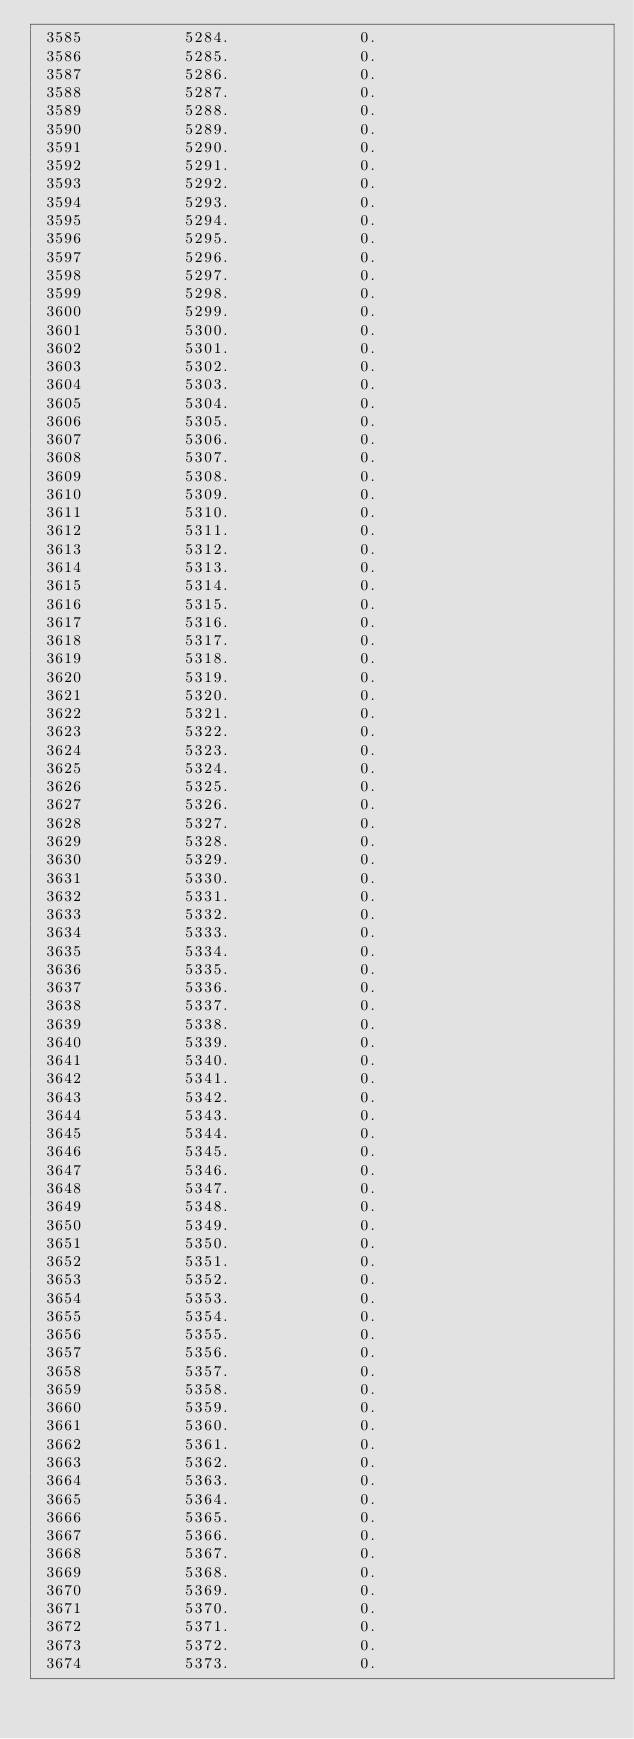Convert code to text. <code><loc_0><loc_0><loc_500><loc_500><_SQL_> 3585           5284.              0.
 3586           5285.              0.
 3587           5286.              0.
 3588           5287.              0.
 3589           5288.              0.
 3590           5289.              0.
 3591           5290.              0.
 3592           5291.              0.
 3593           5292.              0.
 3594           5293.              0.
 3595           5294.              0.
 3596           5295.              0.
 3597           5296.              0.
 3598           5297.              0.
 3599           5298.              0.
 3600           5299.              0.
 3601           5300.              0.
 3602           5301.              0.
 3603           5302.              0.
 3604           5303.              0.
 3605           5304.              0.
 3606           5305.              0.
 3607           5306.              0.
 3608           5307.              0.
 3609           5308.              0.
 3610           5309.              0.
 3611           5310.              0.
 3612           5311.              0.
 3613           5312.              0.
 3614           5313.              0.
 3615           5314.              0.
 3616           5315.              0.
 3617           5316.              0.
 3618           5317.              0.
 3619           5318.              0.
 3620           5319.              0.
 3621           5320.              0.
 3622           5321.              0.
 3623           5322.              0.
 3624           5323.              0.
 3625           5324.              0.
 3626           5325.              0.
 3627           5326.              0.
 3628           5327.              0.
 3629           5328.              0.
 3630           5329.              0.
 3631           5330.              0.
 3632           5331.              0.
 3633           5332.              0.
 3634           5333.              0.
 3635           5334.              0.
 3636           5335.              0.
 3637           5336.              0.
 3638           5337.              0.
 3639           5338.              0.
 3640           5339.              0.
 3641           5340.              0.
 3642           5341.              0.
 3643           5342.              0.
 3644           5343.              0.
 3645           5344.              0.
 3646           5345.              0.
 3647           5346.              0.
 3648           5347.              0.
 3649           5348.              0.
 3650           5349.              0.
 3651           5350.              0.
 3652           5351.              0.
 3653           5352.              0.
 3654           5353.              0.
 3655           5354.              0.
 3656           5355.              0.
 3657           5356.              0.
 3658           5357.              0.
 3659           5358.              0.
 3660           5359.              0.
 3661           5360.              0.
 3662           5361.              0.
 3663           5362.              0.
 3664           5363.              0.
 3665           5364.              0.
 3666           5365.              0.
 3667           5366.              0.
 3668           5367.              0.
 3669           5368.              0.
 3670           5369.              0.
 3671           5370.              0.
 3672           5371.              0.
 3673           5372.              0.
 3674           5373.              0.</code> 